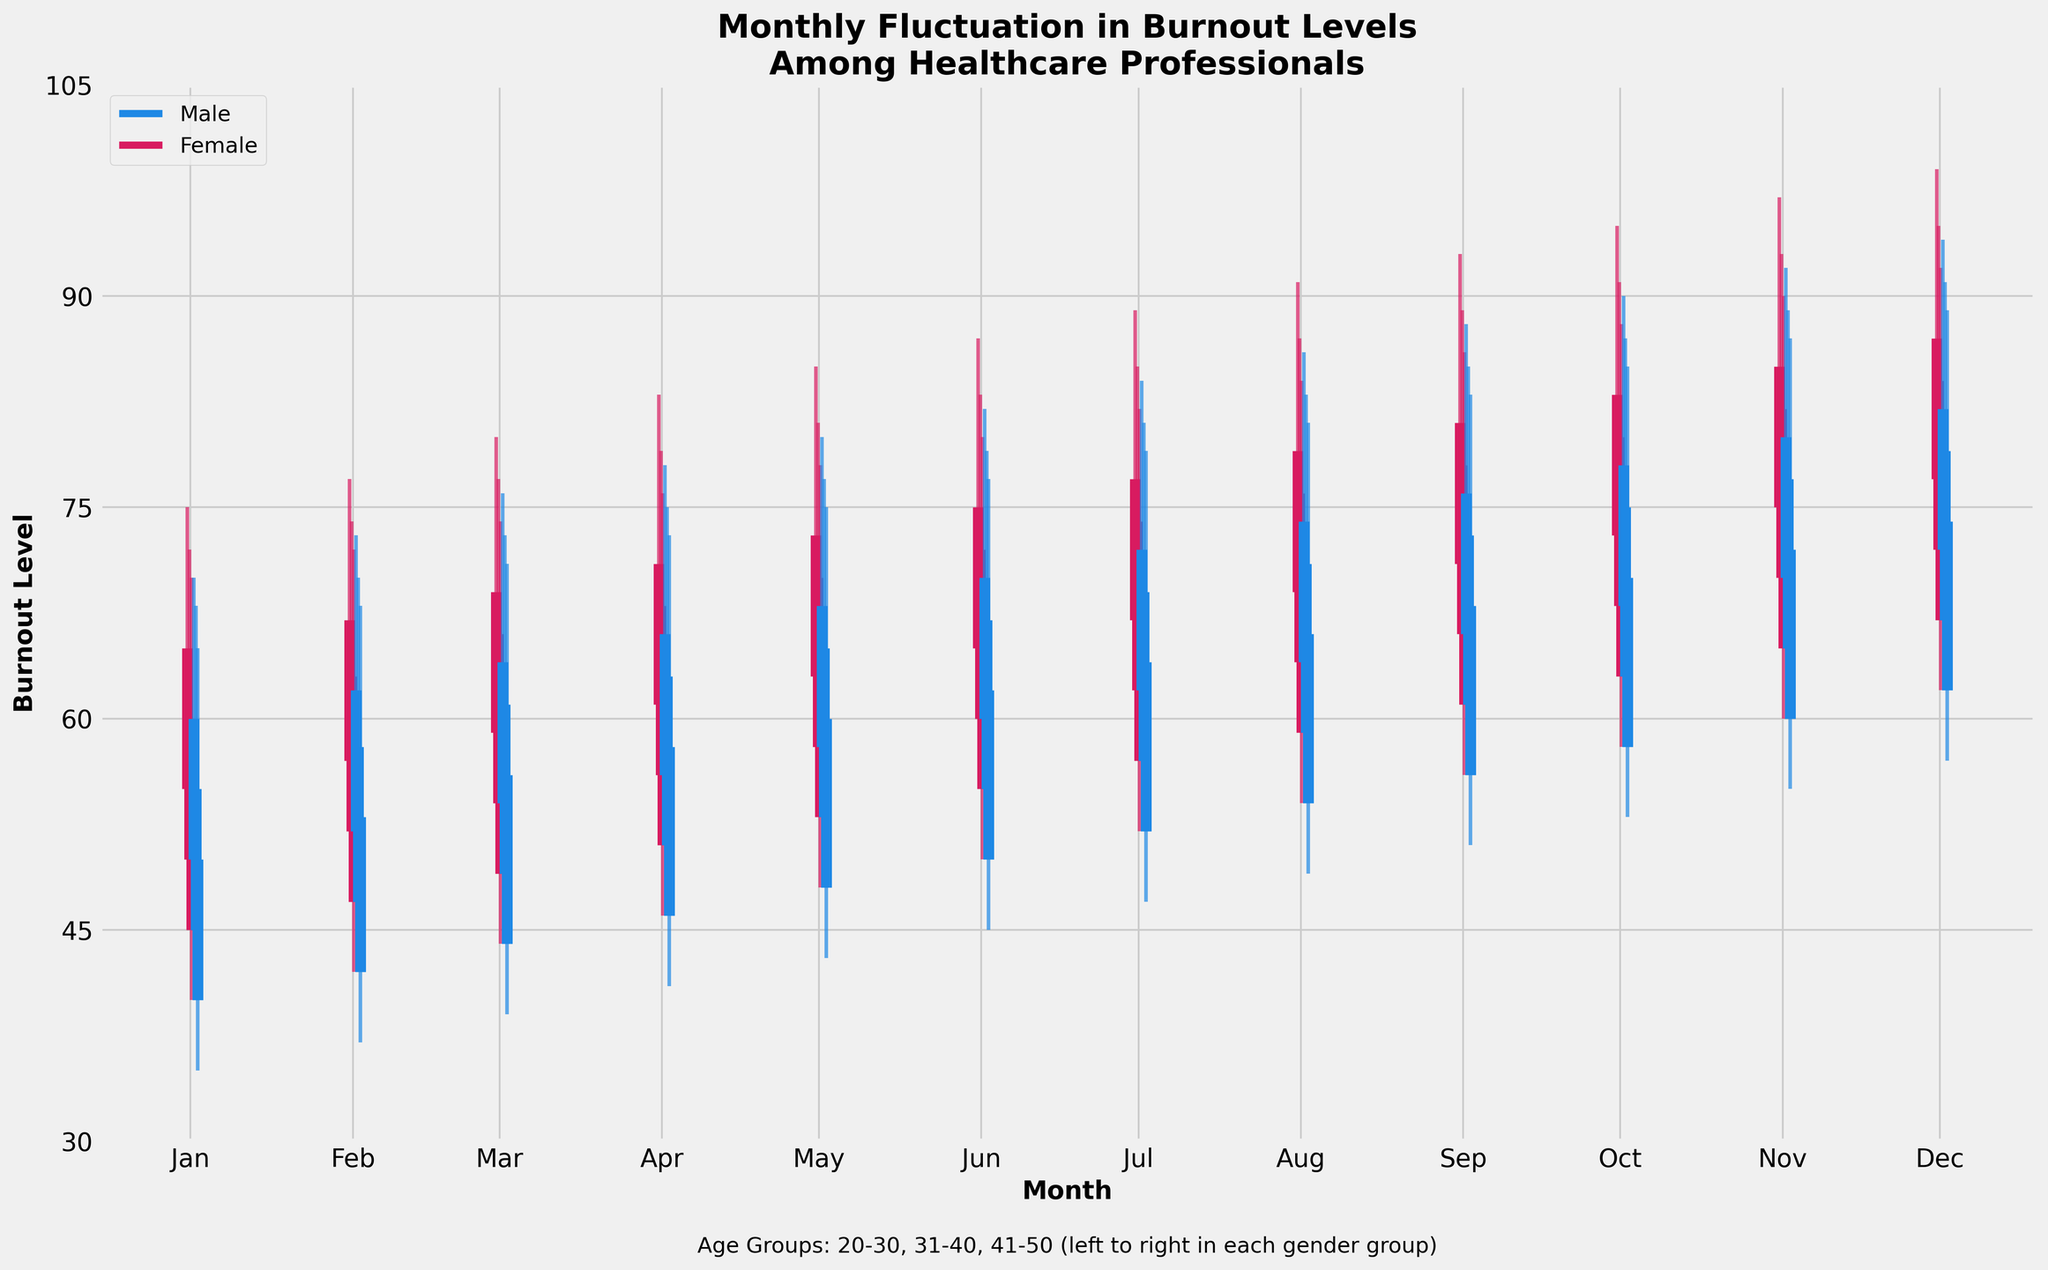What's the title of the plot? The title of the plot is displayed at the top of the plot and it provides a summary of what the plot is about.
Answer: Monthly Fluctuation in Burnout Levels Among Healthcare Professionals How many age groups are compared in the plot? The age groups are represented by different segments within each gender group. Count the distinct age groups listed in the annotations or labels.
Answer: Three (20-30, 31-40, 41-50) Which gender has the highest burnout level in December for the age group 20-30? Look at the candlestick for December corresponding to the age group 20-30 and compare the highest value (top of the candlestick) for both Male and Female.
Answer: Female What is the range of burnout levels for Males aged 31-40 in June? Identify the June candlestick for Males aged 31-40. The range is calculated by subtracting the low value from the high value.
Answer: 29 (79-50) Which month shows the lowest close burnout level for Females aged 41-50? Look at the candlesticks for Females aged 41-50 and find the month where the close value (the shorter bar) is the lowest.
Answer: January Compare the average close burnout level in May across all age groups for Males and Females. Which gender has a higher average? For both Males and Females, find the close burnout levels for all age groups in May, sum them up and divide by the number of age groups.
Answer: Female What is the difference between the high burnout level and the close burnout level for Males aged 20-30 in March? Find the values for the high burnout level and the close burnout level in March for Males aged 20-30, then subtract the close value from the high value.
Answer: 12 (76-64) Which age group shows the most consistent burnout levels throughout the year for Females? Look at the candlesticks for each age group of Females and observe which group has the narrowest range of fluctuations from month to month.
Answer: 41-50 What pattern can you observe in the burnout levels for Females aged 31-40 from January to December? Track the candlesticks for Females aged 31-40 across each month and describe any upward or downward trends in the burnout levels.
Answer: Increasing trend 